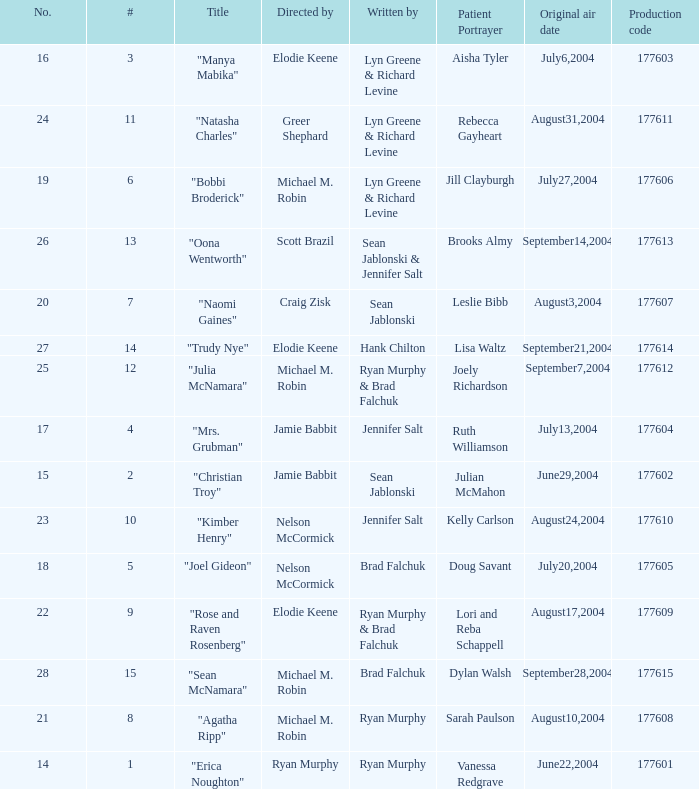How many episodes are numbered 4 in the season? 1.0. 